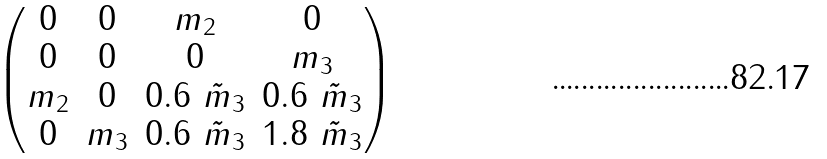Convert formula to latex. <formula><loc_0><loc_0><loc_500><loc_500>\begin{pmatrix} 0 & 0 & m _ { 2 } & 0 \\ 0 & 0 & 0 & m _ { 3 } \\ m _ { 2 } & 0 & 0 . 6 \ \tilde { m } _ { 3 } & 0 . 6 \ \tilde { m } _ { 3 } \\ 0 & m _ { 3 } & 0 . 6 \ \tilde { m } _ { 3 } & 1 . 8 \ \tilde { m } _ { 3 } \end{pmatrix}</formula> 